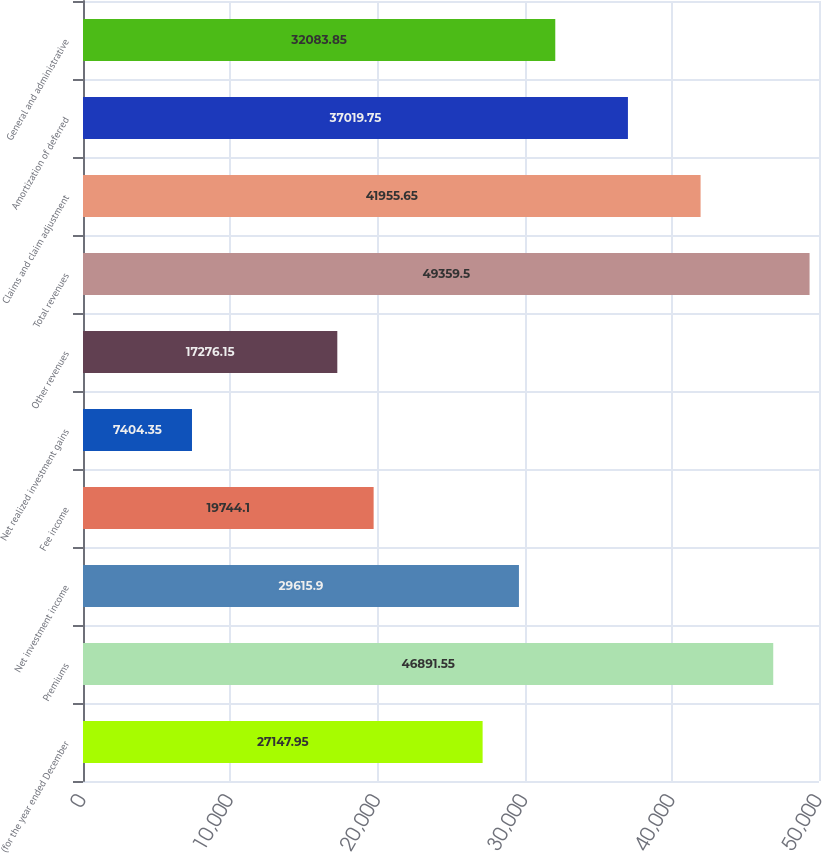<chart> <loc_0><loc_0><loc_500><loc_500><bar_chart><fcel>(for the year ended December<fcel>Premiums<fcel>Net investment income<fcel>Fee income<fcel>Net realized investment gains<fcel>Other revenues<fcel>Total revenues<fcel>Claims and claim adjustment<fcel>Amortization of deferred<fcel>General and administrative<nl><fcel>27148<fcel>46891.6<fcel>29615.9<fcel>19744.1<fcel>7404.35<fcel>17276.2<fcel>49359.5<fcel>41955.7<fcel>37019.8<fcel>32083.8<nl></chart> 